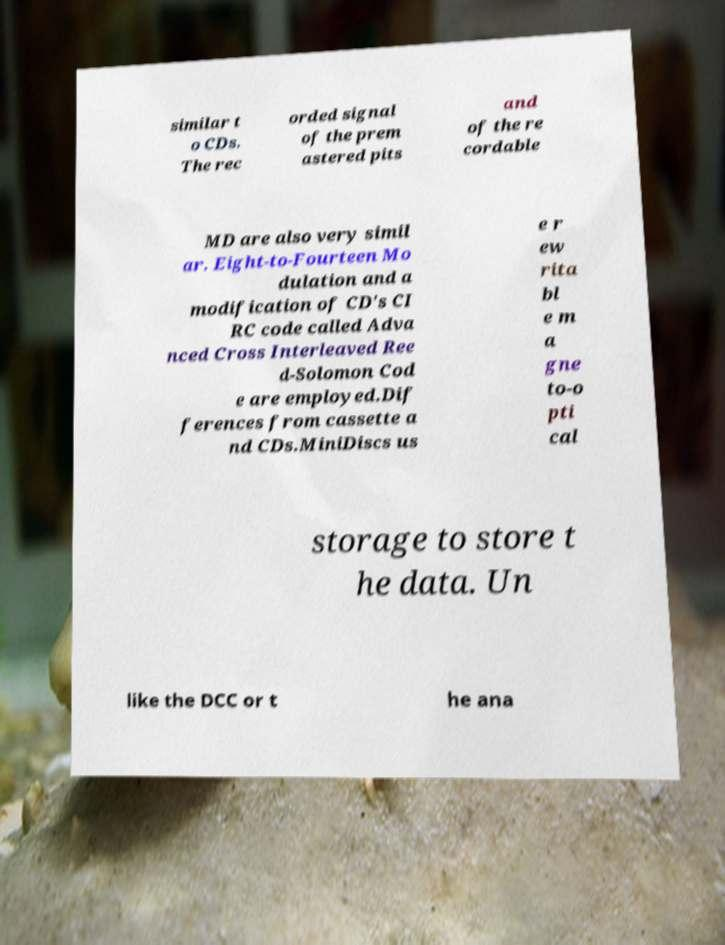For documentation purposes, I need the text within this image transcribed. Could you provide that? similar t o CDs. The rec orded signal of the prem astered pits and of the re cordable MD are also very simil ar. Eight-to-Fourteen Mo dulation and a modification of CD's CI RC code called Adva nced Cross Interleaved Ree d-Solomon Cod e are employed.Dif ferences from cassette a nd CDs.MiniDiscs us e r ew rita bl e m a gne to-o pti cal storage to store t he data. Un like the DCC or t he ana 